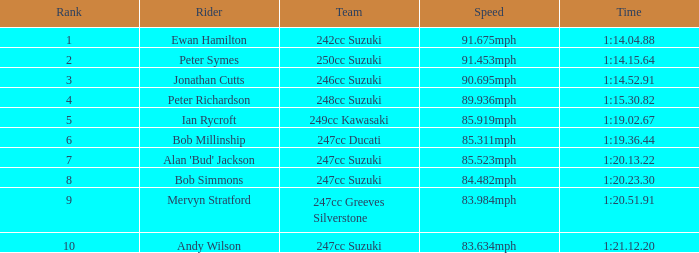Which team had a rank under 4 with a time of 1:14.04.88? 242cc Suzuki. 